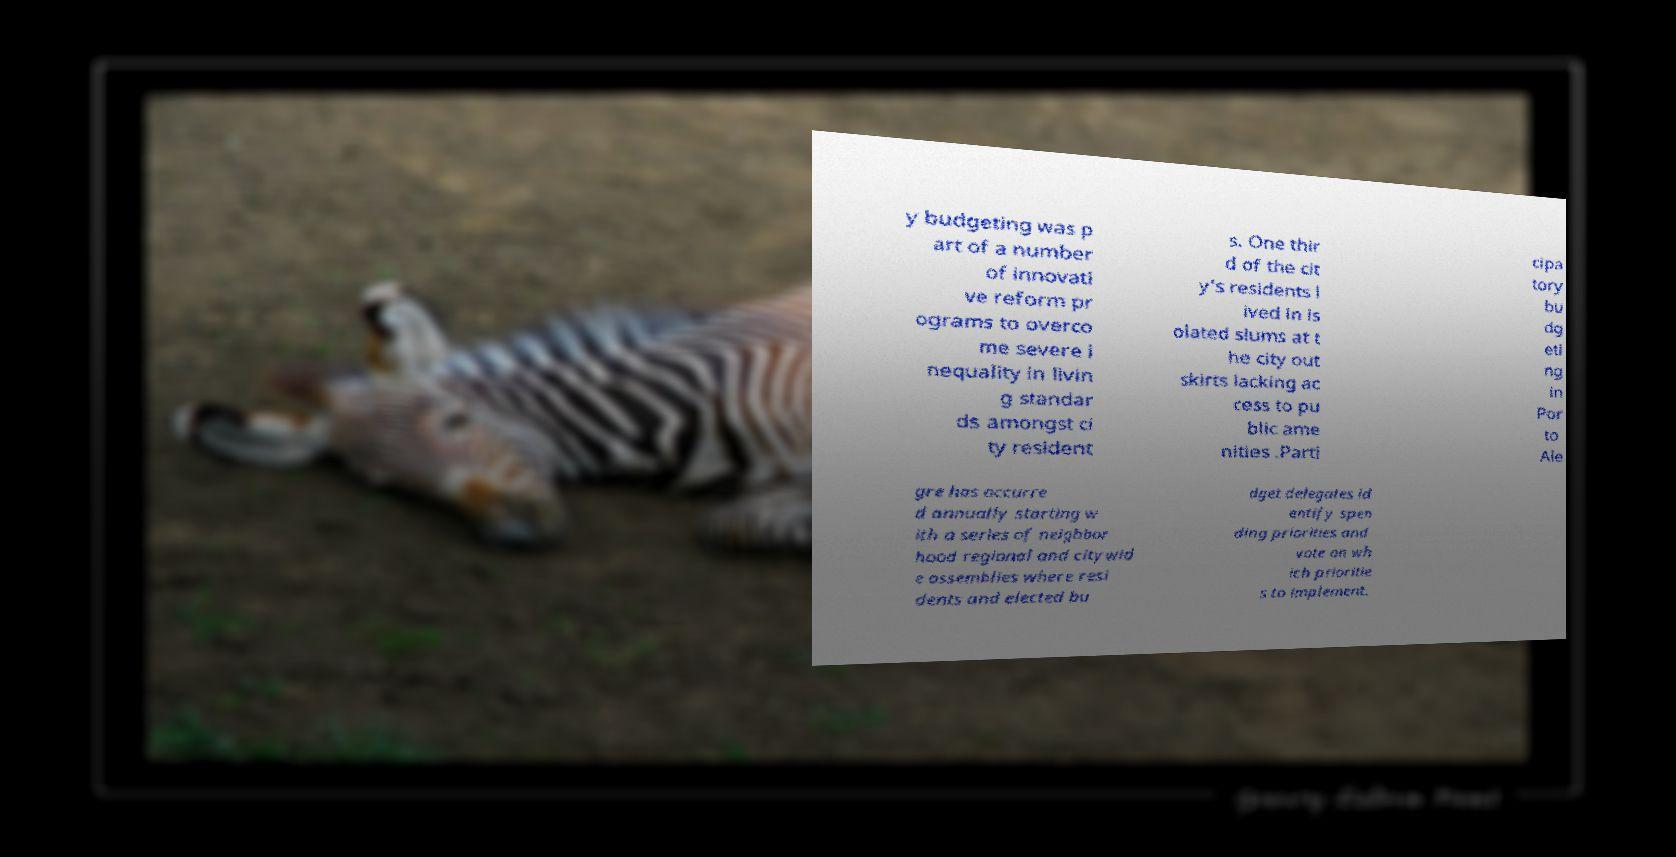What messages or text are displayed in this image? I need them in a readable, typed format. y budgeting was p art of a number of innovati ve reform pr ograms to overco me severe i nequality in livin g standar ds amongst ci ty resident s. One thir d of the cit y's residents l ived in is olated slums at t he city out skirts lacking ac cess to pu blic ame nities .Parti cipa tory bu dg eti ng in Por to Ale gre has occurre d annually starting w ith a series of neighbor hood regional and citywid e assemblies where resi dents and elected bu dget delegates id entify spen ding priorities and vote on wh ich prioritie s to implement. 